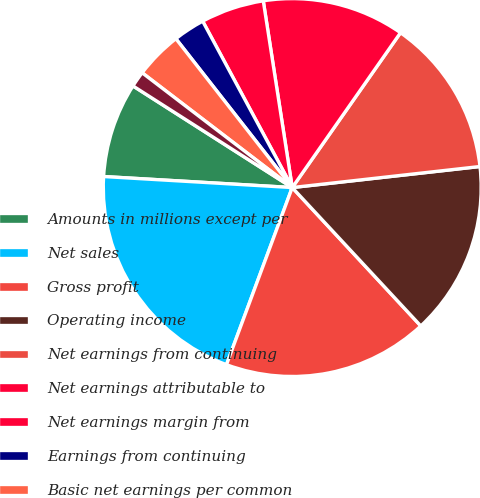Convert chart. <chart><loc_0><loc_0><loc_500><loc_500><pie_chart><fcel>Amounts in millions except per<fcel>Net sales<fcel>Gross profit<fcel>Operating income<fcel>Net earnings from continuing<fcel>Net earnings attributable to<fcel>Net earnings margin from<fcel>Earnings from continuing<fcel>Basic net earnings per common<fcel>Diluted net earnings per<nl><fcel>8.11%<fcel>20.27%<fcel>17.57%<fcel>14.86%<fcel>13.51%<fcel>12.16%<fcel>5.41%<fcel>2.7%<fcel>4.05%<fcel>1.35%<nl></chart> 